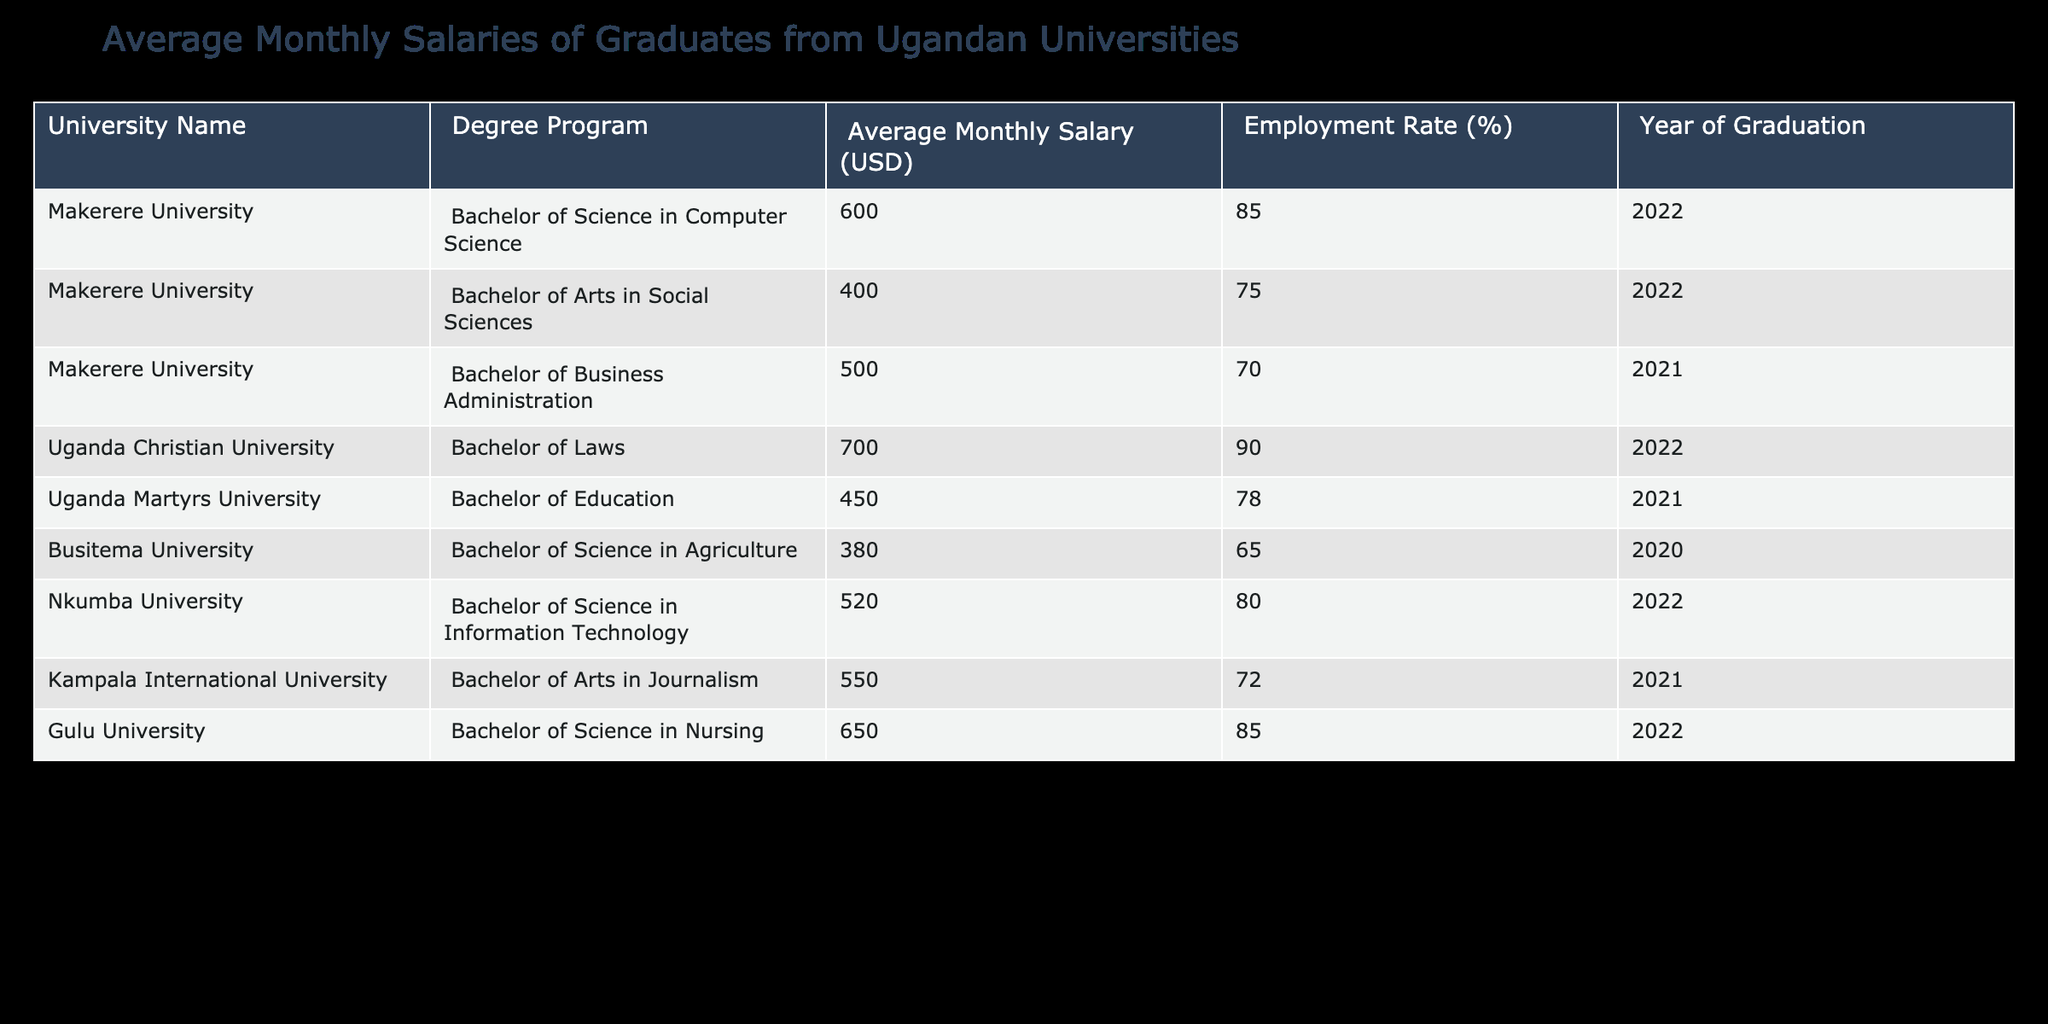What is the average monthly salary of graduates from Makerere University? From the table, the average monthly salary for Makerere graduates in different degree programs is: Bachelor of Science in Computer Science (600), Bachelor of Arts in Social Sciences (400), and Bachelor of Business Administration (500). To find the average, we sum these salaries: 600 + 400 + 500 = 1500. Dividing by the number of programs (3), we get an average of 1500/3 = 500.
Answer: 500 Which degree program has the highest average monthly salary? The table lists the average monthly salaries for various degree programs. The Bachelor of Laws from Uganda Christian University has the highest salary at 700 USD, followed by Bachelor of Science in Nursing from Gulu University at 650 USD. Thus, the highest salary is 700 USD.
Answer: 700 Is the employment rate for graduates from Busitema University above 70%? According to the table, the employment rate for graduates from Busitema University is 65%. Since this is less than 70%, the statement is false.
Answer: No What is the total average monthly salary of graduates who studied education-related programs? The relevant programs from the table are Bachelor of Education from Uganda Martyrs University, which has a salary of 450. There are no other education-related programs mentioned. Therefore, the total average salary for education graduates is simply 450.
Answer: 450 If you compare the average monthly salaries of Nkumba University and Kampala International University, which one is higher? Nkumba University has an average monthly salary of 520 USD for its Bachelor of Science in Information Technology. Kampala International University offers a Bachelor of Arts in Journalism with an average salary of 550 USD. Since 550 is greater than 520, Kampala International University has the higher average salary.
Answer: Kampala International University What is the cumulative average salary of graduates from both Makerere University and Uganda Christian University? The average salaries from Makerere University (500) and Uganda Christian University (700) can be summed: 500 + 700 = 1200. Then, divide by the number of universities (2): 1200 / 2 = 600. So, the cumulative average salary is 600.
Answer: 600 Is the employment rate for graduates of Gulu University equal to or greater than 85%? The table shows that Gulu University has an employment rate of 85%. Since the statement includes equality as well as being greater, it is true that 85% is equal to 85%.
Answer: Yes What is the difference between the average salaries of the highest and lowest-paying degree programs? The highest-paying degree program is Bachelor of Laws from Uganda Christian University (700), and the lowest-paying is Bachelor of Science in Agriculture from Busitema University (380). The difference in salaries is calculated as 700 - 380 = 320.
Answer: 320 Which university has a higher employment rate: Uganda Christian University or Kampala International University? The employment rate for Uganda Christian University is 90%, while Kampala International University has an employment rate of 72%. Since 90% is greater than 72%, Uganda Christian University has a higher employment rate.
Answer: Uganda Christian University 